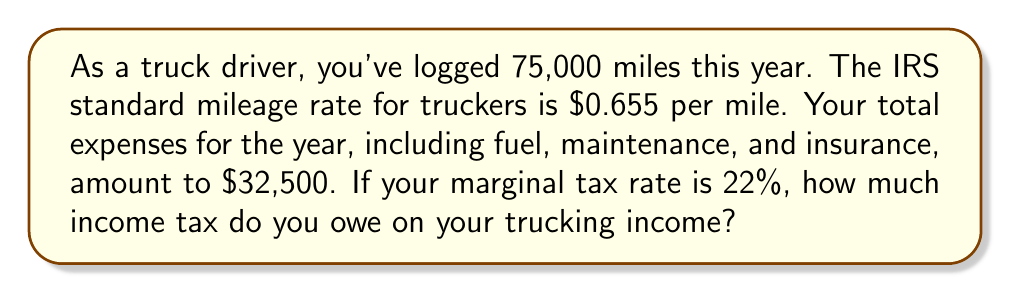Show me your answer to this math problem. Let's break this down step-by-step:

1. Calculate your gross income based on mileage:
   $$ \text{Gross Income} = \text{Miles Driven} \times \text{Mileage Rate} $$
   $$ \text{Gross Income} = 75,000 \times $0.655 = $49,125 $$

2. Calculate your net income by subtracting expenses:
   $$ \text{Net Income} = \text{Gross Income} - \text{Expenses} $$
   $$ \text{Net Income} = $49,125 - $32,500 = $16,625 $$

3. Calculate the income tax owed using the marginal tax rate:
   $$ \text{Income Tax} = \text{Net Income} \times \text{Marginal Tax Rate} $$
   $$ \text{Income Tax} = $16,625 \times 0.22 = $3,657.50 $$

Therefore, the income tax owed on your trucking income is $3,657.50.
Answer: $3,657.50 